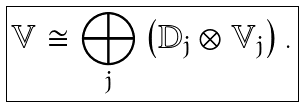Convert formula to latex. <formula><loc_0><loc_0><loc_500><loc_500>\boxed { \mathbb { V } \cong \bigoplus _ { j } \left ( \mathbb { D } _ { j } \otimes \mathbb { V } _ { j } \right ) . }</formula> 